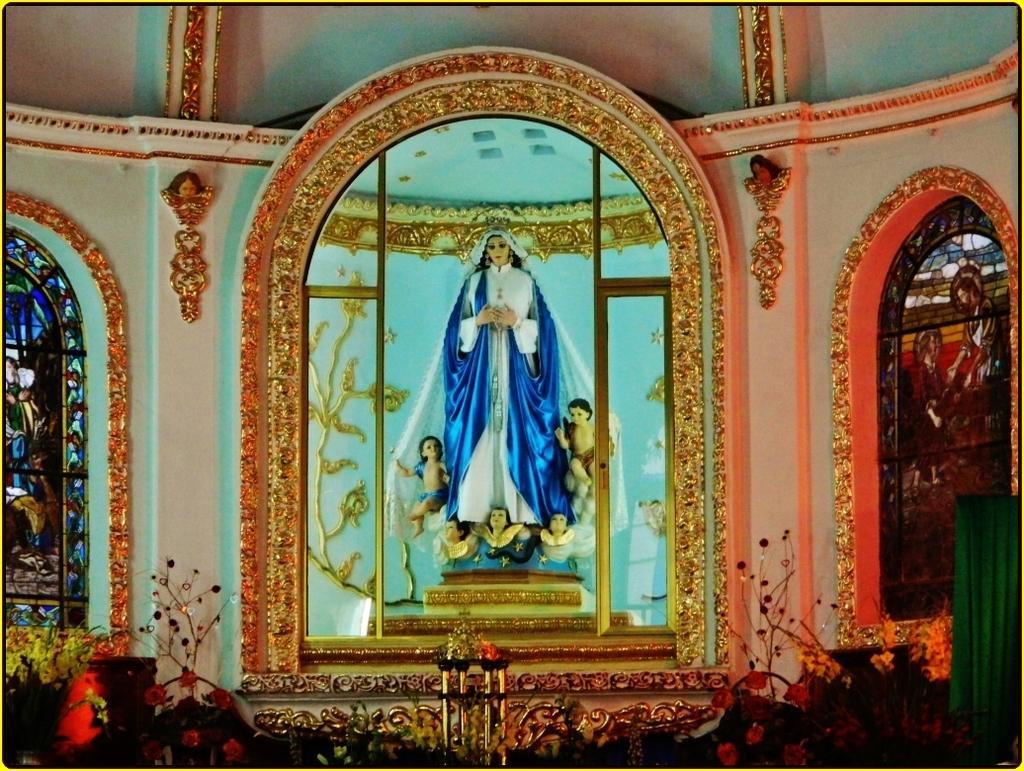Can you describe this image briefly? This picture describes about inside view of a church, in the church we can find a statue and stained glass on the left and right side of the image. 